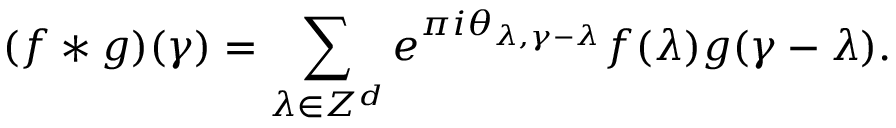Convert formula to latex. <formula><loc_0><loc_0><loc_500><loc_500>( f * g ) ( \gamma ) = \sum _ { \lambda \in Z ^ { d } } e ^ { \pi i \theta _ { \lambda , \gamma - \lambda } } f ( \lambda ) g ( \gamma - \lambda ) .</formula> 